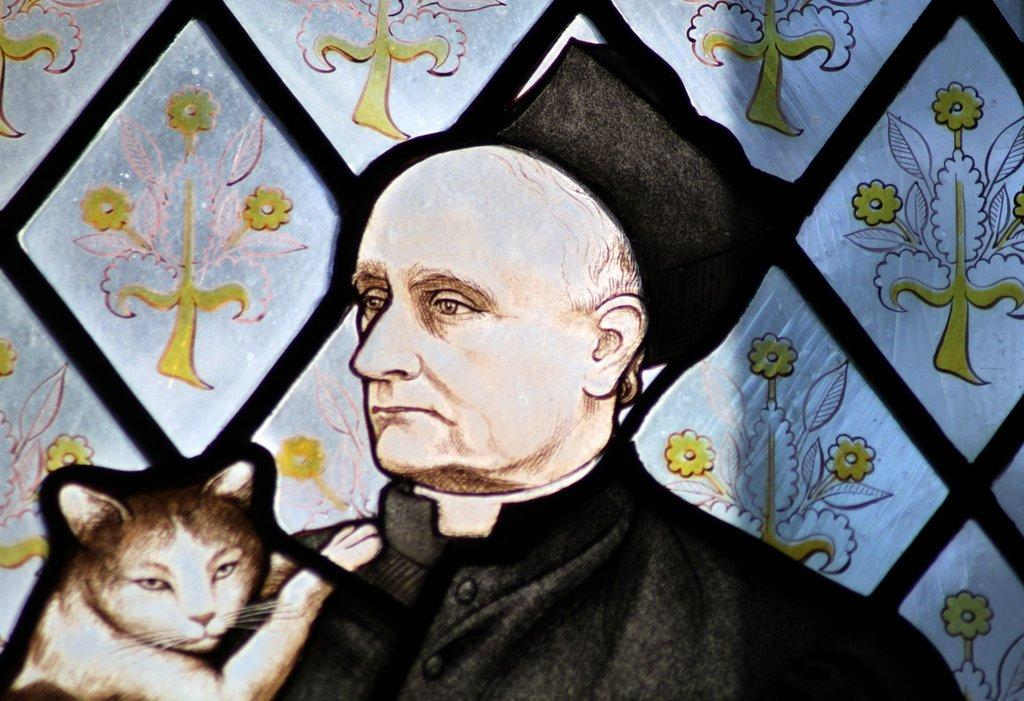What type of animal is in the image? There is a cat in the image. Who or what else is present in the image? There is a person in the image. What other object or element can be seen in the image? There is a flower in the image. What type of wound can be seen on the cat's eye in the image? There is no wound or eye visible on the cat in the image; it is a healthy cat. 